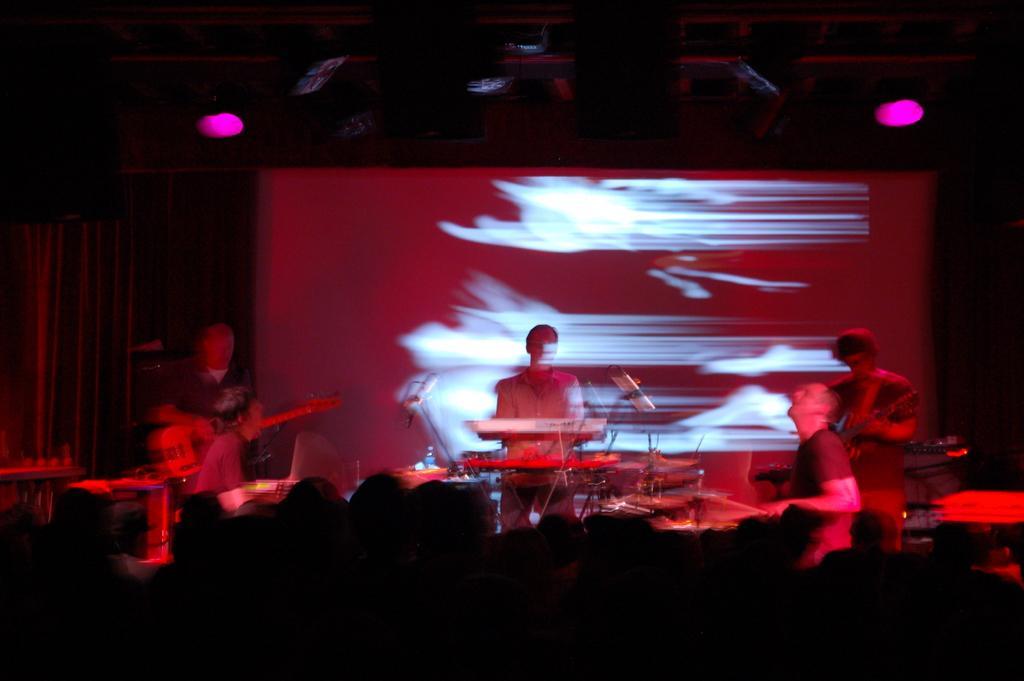Can you describe this image briefly? In the picture we can see three people are giving a musical performance playing some musical instruments and behind them, we can see a wall and to the ceiling we can see two lights which are pink in color. 